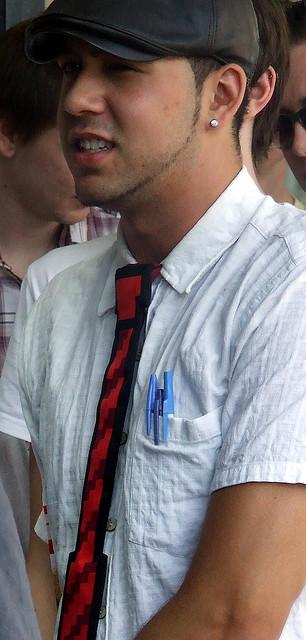What company is known for making the objects in the man's pocket? bic 